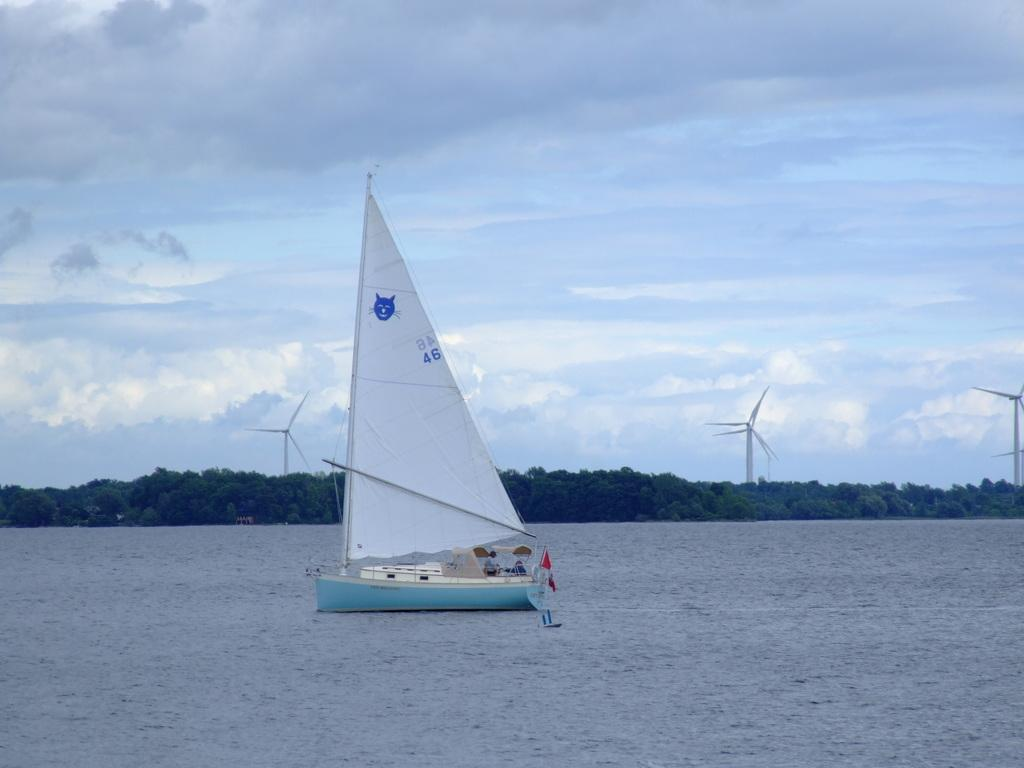What is the main subject of the image? The main subject of the image is a boat. Where is the boat located in the image? The boat is on the water surface in the image. What can be seen in the background of the image? There are trees in the background of the image. Can you see any fangs on the boat in the image? There are no fangs present in the image, as it features a boat on the water surface with trees in the background. 